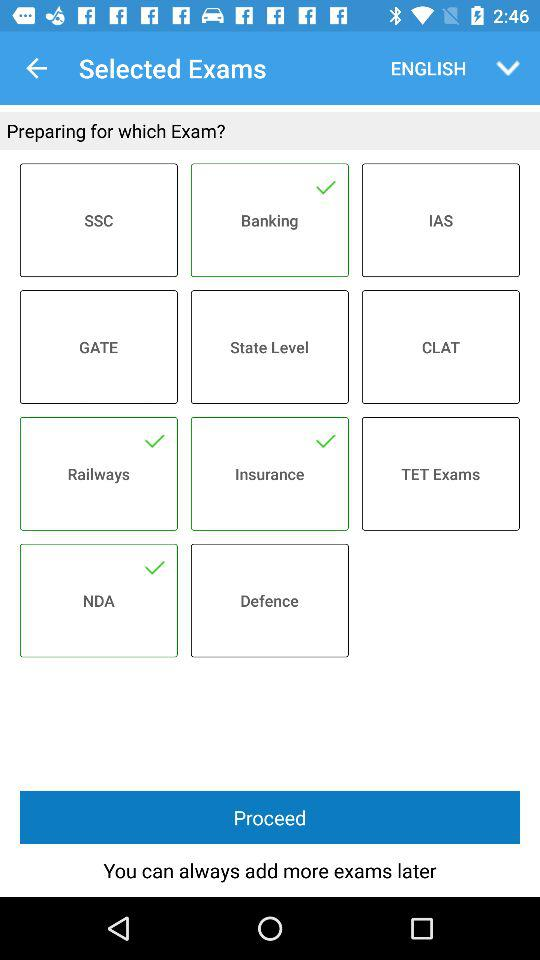Which exam options are selected? The selected exam options are "Banking", "Railways", "Insurance" and "NDA". 